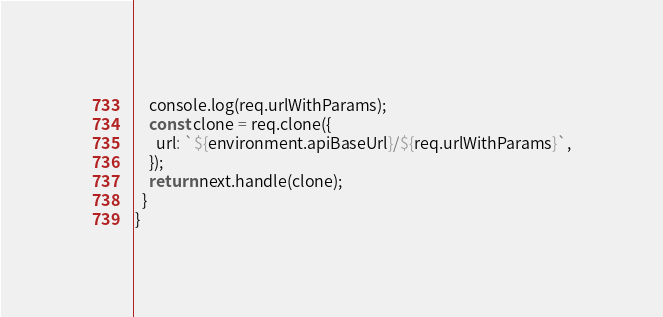<code> <loc_0><loc_0><loc_500><loc_500><_TypeScript_>    console.log(req.urlWithParams);
    const clone = req.clone({
      url: `${environment.apiBaseUrl}/${req.urlWithParams}`,
    });
    return next.handle(clone);
  }
}
</code> 